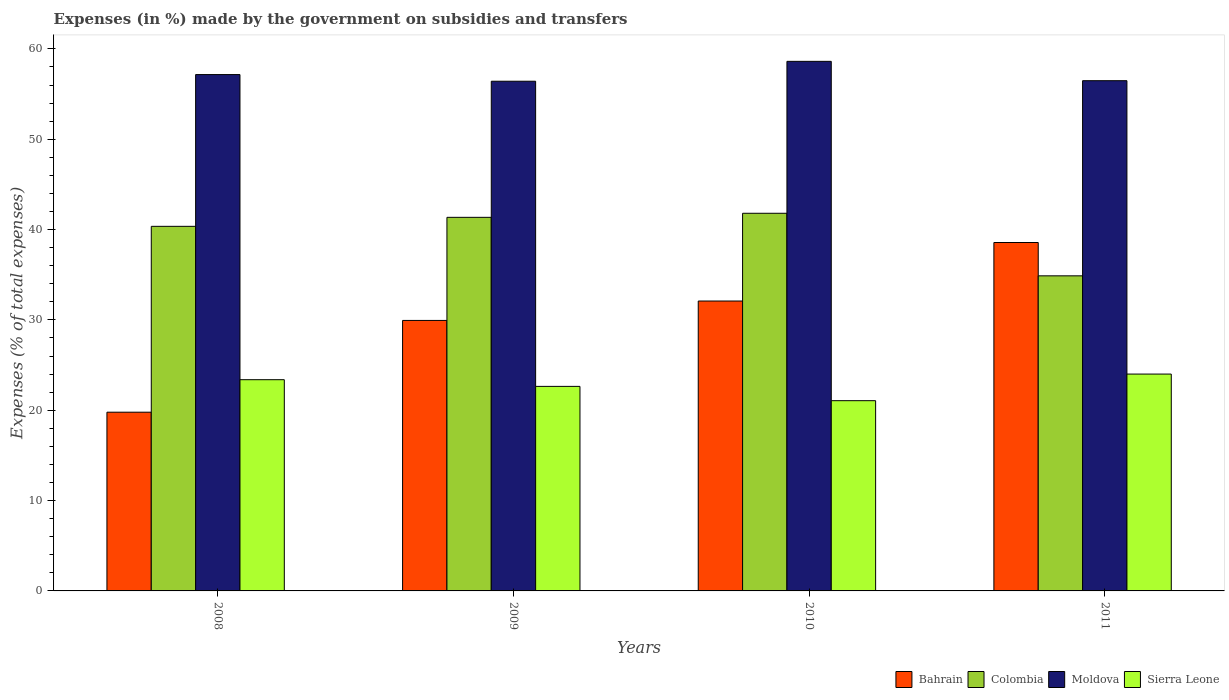How many different coloured bars are there?
Offer a very short reply. 4. How many groups of bars are there?
Your answer should be very brief. 4. Are the number of bars on each tick of the X-axis equal?
Your response must be concise. Yes. What is the label of the 4th group of bars from the left?
Provide a succinct answer. 2011. What is the percentage of expenses made by the government on subsidies and transfers in Moldova in 2010?
Offer a very short reply. 58.62. Across all years, what is the maximum percentage of expenses made by the government on subsidies and transfers in Colombia?
Provide a short and direct response. 41.81. Across all years, what is the minimum percentage of expenses made by the government on subsidies and transfers in Bahrain?
Your answer should be compact. 19.78. In which year was the percentage of expenses made by the government on subsidies and transfers in Colombia minimum?
Ensure brevity in your answer.  2011. What is the total percentage of expenses made by the government on subsidies and transfers in Moldova in the graph?
Offer a terse response. 228.69. What is the difference between the percentage of expenses made by the government on subsidies and transfers in Moldova in 2008 and that in 2010?
Your answer should be very brief. -1.46. What is the difference between the percentage of expenses made by the government on subsidies and transfers in Bahrain in 2011 and the percentage of expenses made by the government on subsidies and transfers in Moldova in 2010?
Your response must be concise. -20.05. What is the average percentage of expenses made by the government on subsidies and transfers in Sierra Leone per year?
Keep it short and to the point. 22.77. In the year 2009, what is the difference between the percentage of expenses made by the government on subsidies and transfers in Colombia and percentage of expenses made by the government on subsidies and transfers in Sierra Leone?
Make the answer very short. 18.71. In how many years, is the percentage of expenses made by the government on subsidies and transfers in Sierra Leone greater than 48 %?
Your answer should be very brief. 0. What is the ratio of the percentage of expenses made by the government on subsidies and transfers in Sierra Leone in 2008 to that in 2009?
Offer a terse response. 1.03. Is the percentage of expenses made by the government on subsidies and transfers in Moldova in 2010 less than that in 2011?
Offer a terse response. No. What is the difference between the highest and the second highest percentage of expenses made by the government on subsidies and transfers in Bahrain?
Provide a succinct answer. 6.48. What is the difference between the highest and the lowest percentage of expenses made by the government on subsidies and transfers in Colombia?
Offer a very short reply. 6.93. In how many years, is the percentage of expenses made by the government on subsidies and transfers in Colombia greater than the average percentage of expenses made by the government on subsidies and transfers in Colombia taken over all years?
Offer a terse response. 3. Is it the case that in every year, the sum of the percentage of expenses made by the government on subsidies and transfers in Bahrain and percentage of expenses made by the government on subsidies and transfers in Sierra Leone is greater than the sum of percentage of expenses made by the government on subsidies and transfers in Moldova and percentage of expenses made by the government on subsidies and transfers in Colombia?
Your answer should be compact. No. What does the 2nd bar from the right in 2010 represents?
Your answer should be very brief. Moldova. Is it the case that in every year, the sum of the percentage of expenses made by the government on subsidies and transfers in Colombia and percentage of expenses made by the government on subsidies and transfers in Moldova is greater than the percentage of expenses made by the government on subsidies and transfers in Bahrain?
Offer a very short reply. Yes. Are the values on the major ticks of Y-axis written in scientific E-notation?
Your answer should be very brief. No. Where does the legend appear in the graph?
Offer a terse response. Bottom right. What is the title of the graph?
Offer a very short reply. Expenses (in %) made by the government on subsidies and transfers. What is the label or title of the Y-axis?
Keep it short and to the point. Expenses (% of total expenses). What is the Expenses (% of total expenses) of Bahrain in 2008?
Provide a succinct answer. 19.78. What is the Expenses (% of total expenses) in Colombia in 2008?
Your response must be concise. 40.36. What is the Expenses (% of total expenses) of Moldova in 2008?
Keep it short and to the point. 57.16. What is the Expenses (% of total expenses) in Sierra Leone in 2008?
Your answer should be very brief. 23.38. What is the Expenses (% of total expenses) in Bahrain in 2009?
Ensure brevity in your answer.  29.94. What is the Expenses (% of total expenses) in Colombia in 2009?
Your answer should be very brief. 41.36. What is the Expenses (% of total expenses) in Moldova in 2009?
Make the answer very short. 56.42. What is the Expenses (% of total expenses) of Sierra Leone in 2009?
Give a very brief answer. 22.64. What is the Expenses (% of total expenses) in Bahrain in 2010?
Give a very brief answer. 32.09. What is the Expenses (% of total expenses) in Colombia in 2010?
Make the answer very short. 41.81. What is the Expenses (% of total expenses) of Moldova in 2010?
Ensure brevity in your answer.  58.62. What is the Expenses (% of total expenses) of Sierra Leone in 2010?
Give a very brief answer. 21.06. What is the Expenses (% of total expenses) of Bahrain in 2011?
Make the answer very short. 38.57. What is the Expenses (% of total expenses) of Colombia in 2011?
Keep it short and to the point. 34.88. What is the Expenses (% of total expenses) in Moldova in 2011?
Provide a short and direct response. 56.48. What is the Expenses (% of total expenses) of Sierra Leone in 2011?
Your answer should be compact. 24.01. Across all years, what is the maximum Expenses (% of total expenses) in Bahrain?
Provide a succinct answer. 38.57. Across all years, what is the maximum Expenses (% of total expenses) in Colombia?
Offer a very short reply. 41.81. Across all years, what is the maximum Expenses (% of total expenses) of Moldova?
Ensure brevity in your answer.  58.62. Across all years, what is the maximum Expenses (% of total expenses) of Sierra Leone?
Keep it short and to the point. 24.01. Across all years, what is the minimum Expenses (% of total expenses) of Bahrain?
Your response must be concise. 19.78. Across all years, what is the minimum Expenses (% of total expenses) of Colombia?
Offer a terse response. 34.88. Across all years, what is the minimum Expenses (% of total expenses) in Moldova?
Give a very brief answer. 56.42. Across all years, what is the minimum Expenses (% of total expenses) of Sierra Leone?
Make the answer very short. 21.06. What is the total Expenses (% of total expenses) of Bahrain in the graph?
Offer a very short reply. 120.39. What is the total Expenses (% of total expenses) in Colombia in the graph?
Keep it short and to the point. 158.4. What is the total Expenses (% of total expenses) of Moldova in the graph?
Your response must be concise. 228.69. What is the total Expenses (% of total expenses) of Sierra Leone in the graph?
Keep it short and to the point. 91.09. What is the difference between the Expenses (% of total expenses) in Bahrain in 2008 and that in 2009?
Your answer should be very brief. -10.16. What is the difference between the Expenses (% of total expenses) in Colombia in 2008 and that in 2009?
Keep it short and to the point. -1. What is the difference between the Expenses (% of total expenses) in Moldova in 2008 and that in 2009?
Your answer should be very brief. 0.74. What is the difference between the Expenses (% of total expenses) of Sierra Leone in 2008 and that in 2009?
Keep it short and to the point. 0.74. What is the difference between the Expenses (% of total expenses) in Bahrain in 2008 and that in 2010?
Offer a terse response. -12.31. What is the difference between the Expenses (% of total expenses) in Colombia in 2008 and that in 2010?
Provide a short and direct response. -1.45. What is the difference between the Expenses (% of total expenses) of Moldova in 2008 and that in 2010?
Your answer should be very brief. -1.46. What is the difference between the Expenses (% of total expenses) in Sierra Leone in 2008 and that in 2010?
Your answer should be very brief. 2.32. What is the difference between the Expenses (% of total expenses) of Bahrain in 2008 and that in 2011?
Offer a terse response. -18.78. What is the difference between the Expenses (% of total expenses) in Colombia in 2008 and that in 2011?
Your response must be concise. 5.48. What is the difference between the Expenses (% of total expenses) in Moldova in 2008 and that in 2011?
Offer a very short reply. 0.68. What is the difference between the Expenses (% of total expenses) in Sierra Leone in 2008 and that in 2011?
Give a very brief answer. -0.62. What is the difference between the Expenses (% of total expenses) in Bahrain in 2009 and that in 2010?
Your answer should be compact. -2.15. What is the difference between the Expenses (% of total expenses) in Colombia in 2009 and that in 2010?
Keep it short and to the point. -0.45. What is the difference between the Expenses (% of total expenses) in Moldova in 2009 and that in 2010?
Ensure brevity in your answer.  -2.2. What is the difference between the Expenses (% of total expenses) of Sierra Leone in 2009 and that in 2010?
Offer a very short reply. 1.58. What is the difference between the Expenses (% of total expenses) in Bahrain in 2009 and that in 2011?
Keep it short and to the point. -8.62. What is the difference between the Expenses (% of total expenses) of Colombia in 2009 and that in 2011?
Offer a very short reply. 6.47. What is the difference between the Expenses (% of total expenses) of Moldova in 2009 and that in 2011?
Your answer should be very brief. -0.06. What is the difference between the Expenses (% of total expenses) in Sierra Leone in 2009 and that in 2011?
Keep it short and to the point. -1.36. What is the difference between the Expenses (% of total expenses) in Bahrain in 2010 and that in 2011?
Ensure brevity in your answer.  -6.48. What is the difference between the Expenses (% of total expenses) in Colombia in 2010 and that in 2011?
Your response must be concise. 6.93. What is the difference between the Expenses (% of total expenses) in Moldova in 2010 and that in 2011?
Give a very brief answer. 2.14. What is the difference between the Expenses (% of total expenses) in Sierra Leone in 2010 and that in 2011?
Keep it short and to the point. -2.95. What is the difference between the Expenses (% of total expenses) of Bahrain in 2008 and the Expenses (% of total expenses) of Colombia in 2009?
Your response must be concise. -21.57. What is the difference between the Expenses (% of total expenses) of Bahrain in 2008 and the Expenses (% of total expenses) of Moldova in 2009?
Your answer should be compact. -36.64. What is the difference between the Expenses (% of total expenses) in Bahrain in 2008 and the Expenses (% of total expenses) in Sierra Leone in 2009?
Provide a succinct answer. -2.86. What is the difference between the Expenses (% of total expenses) of Colombia in 2008 and the Expenses (% of total expenses) of Moldova in 2009?
Make the answer very short. -16.06. What is the difference between the Expenses (% of total expenses) in Colombia in 2008 and the Expenses (% of total expenses) in Sierra Leone in 2009?
Offer a terse response. 17.72. What is the difference between the Expenses (% of total expenses) of Moldova in 2008 and the Expenses (% of total expenses) of Sierra Leone in 2009?
Offer a very short reply. 34.52. What is the difference between the Expenses (% of total expenses) in Bahrain in 2008 and the Expenses (% of total expenses) in Colombia in 2010?
Provide a succinct answer. -22.02. What is the difference between the Expenses (% of total expenses) in Bahrain in 2008 and the Expenses (% of total expenses) in Moldova in 2010?
Give a very brief answer. -38.84. What is the difference between the Expenses (% of total expenses) in Bahrain in 2008 and the Expenses (% of total expenses) in Sierra Leone in 2010?
Offer a very short reply. -1.27. What is the difference between the Expenses (% of total expenses) in Colombia in 2008 and the Expenses (% of total expenses) in Moldova in 2010?
Your answer should be very brief. -18.26. What is the difference between the Expenses (% of total expenses) in Colombia in 2008 and the Expenses (% of total expenses) in Sierra Leone in 2010?
Give a very brief answer. 19.3. What is the difference between the Expenses (% of total expenses) in Moldova in 2008 and the Expenses (% of total expenses) in Sierra Leone in 2010?
Provide a short and direct response. 36.1. What is the difference between the Expenses (% of total expenses) of Bahrain in 2008 and the Expenses (% of total expenses) of Colombia in 2011?
Your answer should be compact. -15.1. What is the difference between the Expenses (% of total expenses) in Bahrain in 2008 and the Expenses (% of total expenses) in Moldova in 2011?
Keep it short and to the point. -36.7. What is the difference between the Expenses (% of total expenses) in Bahrain in 2008 and the Expenses (% of total expenses) in Sierra Leone in 2011?
Offer a very short reply. -4.22. What is the difference between the Expenses (% of total expenses) in Colombia in 2008 and the Expenses (% of total expenses) in Moldova in 2011?
Provide a succinct answer. -16.12. What is the difference between the Expenses (% of total expenses) in Colombia in 2008 and the Expenses (% of total expenses) in Sierra Leone in 2011?
Make the answer very short. 16.35. What is the difference between the Expenses (% of total expenses) of Moldova in 2008 and the Expenses (% of total expenses) of Sierra Leone in 2011?
Offer a very short reply. 33.15. What is the difference between the Expenses (% of total expenses) in Bahrain in 2009 and the Expenses (% of total expenses) in Colombia in 2010?
Make the answer very short. -11.86. What is the difference between the Expenses (% of total expenses) in Bahrain in 2009 and the Expenses (% of total expenses) in Moldova in 2010?
Your answer should be compact. -28.68. What is the difference between the Expenses (% of total expenses) of Bahrain in 2009 and the Expenses (% of total expenses) of Sierra Leone in 2010?
Ensure brevity in your answer.  8.88. What is the difference between the Expenses (% of total expenses) in Colombia in 2009 and the Expenses (% of total expenses) in Moldova in 2010?
Your answer should be compact. -17.27. What is the difference between the Expenses (% of total expenses) of Colombia in 2009 and the Expenses (% of total expenses) of Sierra Leone in 2010?
Your answer should be compact. 20.3. What is the difference between the Expenses (% of total expenses) in Moldova in 2009 and the Expenses (% of total expenses) in Sierra Leone in 2010?
Ensure brevity in your answer.  35.36. What is the difference between the Expenses (% of total expenses) of Bahrain in 2009 and the Expenses (% of total expenses) of Colombia in 2011?
Ensure brevity in your answer.  -4.94. What is the difference between the Expenses (% of total expenses) in Bahrain in 2009 and the Expenses (% of total expenses) in Moldova in 2011?
Offer a terse response. -26.54. What is the difference between the Expenses (% of total expenses) of Bahrain in 2009 and the Expenses (% of total expenses) of Sierra Leone in 2011?
Your response must be concise. 5.94. What is the difference between the Expenses (% of total expenses) in Colombia in 2009 and the Expenses (% of total expenses) in Moldova in 2011?
Offer a terse response. -15.13. What is the difference between the Expenses (% of total expenses) in Colombia in 2009 and the Expenses (% of total expenses) in Sierra Leone in 2011?
Provide a succinct answer. 17.35. What is the difference between the Expenses (% of total expenses) of Moldova in 2009 and the Expenses (% of total expenses) of Sierra Leone in 2011?
Your answer should be compact. 32.42. What is the difference between the Expenses (% of total expenses) in Bahrain in 2010 and the Expenses (% of total expenses) in Colombia in 2011?
Keep it short and to the point. -2.79. What is the difference between the Expenses (% of total expenses) of Bahrain in 2010 and the Expenses (% of total expenses) of Moldova in 2011?
Offer a terse response. -24.39. What is the difference between the Expenses (% of total expenses) of Bahrain in 2010 and the Expenses (% of total expenses) of Sierra Leone in 2011?
Provide a short and direct response. 8.09. What is the difference between the Expenses (% of total expenses) of Colombia in 2010 and the Expenses (% of total expenses) of Moldova in 2011?
Give a very brief answer. -14.68. What is the difference between the Expenses (% of total expenses) in Colombia in 2010 and the Expenses (% of total expenses) in Sierra Leone in 2011?
Offer a terse response. 17.8. What is the difference between the Expenses (% of total expenses) in Moldova in 2010 and the Expenses (% of total expenses) in Sierra Leone in 2011?
Provide a short and direct response. 34.62. What is the average Expenses (% of total expenses) of Bahrain per year?
Offer a very short reply. 30.1. What is the average Expenses (% of total expenses) of Colombia per year?
Provide a short and direct response. 39.6. What is the average Expenses (% of total expenses) of Moldova per year?
Your answer should be very brief. 57.17. What is the average Expenses (% of total expenses) of Sierra Leone per year?
Ensure brevity in your answer.  22.77. In the year 2008, what is the difference between the Expenses (% of total expenses) of Bahrain and Expenses (% of total expenses) of Colombia?
Offer a terse response. -20.57. In the year 2008, what is the difference between the Expenses (% of total expenses) of Bahrain and Expenses (% of total expenses) of Moldova?
Offer a terse response. -37.38. In the year 2008, what is the difference between the Expenses (% of total expenses) in Bahrain and Expenses (% of total expenses) in Sierra Leone?
Make the answer very short. -3.6. In the year 2008, what is the difference between the Expenses (% of total expenses) of Colombia and Expenses (% of total expenses) of Moldova?
Ensure brevity in your answer.  -16.8. In the year 2008, what is the difference between the Expenses (% of total expenses) of Colombia and Expenses (% of total expenses) of Sierra Leone?
Keep it short and to the point. 16.98. In the year 2008, what is the difference between the Expenses (% of total expenses) of Moldova and Expenses (% of total expenses) of Sierra Leone?
Keep it short and to the point. 33.78. In the year 2009, what is the difference between the Expenses (% of total expenses) of Bahrain and Expenses (% of total expenses) of Colombia?
Your answer should be compact. -11.41. In the year 2009, what is the difference between the Expenses (% of total expenses) of Bahrain and Expenses (% of total expenses) of Moldova?
Offer a terse response. -26.48. In the year 2009, what is the difference between the Expenses (% of total expenses) of Bahrain and Expenses (% of total expenses) of Sierra Leone?
Keep it short and to the point. 7.3. In the year 2009, what is the difference between the Expenses (% of total expenses) of Colombia and Expenses (% of total expenses) of Moldova?
Keep it short and to the point. -15.07. In the year 2009, what is the difference between the Expenses (% of total expenses) in Colombia and Expenses (% of total expenses) in Sierra Leone?
Your answer should be very brief. 18.71. In the year 2009, what is the difference between the Expenses (% of total expenses) in Moldova and Expenses (% of total expenses) in Sierra Leone?
Provide a succinct answer. 33.78. In the year 2010, what is the difference between the Expenses (% of total expenses) in Bahrain and Expenses (% of total expenses) in Colombia?
Make the answer very short. -9.71. In the year 2010, what is the difference between the Expenses (% of total expenses) of Bahrain and Expenses (% of total expenses) of Moldova?
Keep it short and to the point. -26.53. In the year 2010, what is the difference between the Expenses (% of total expenses) in Bahrain and Expenses (% of total expenses) in Sierra Leone?
Your answer should be compact. 11.03. In the year 2010, what is the difference between the Expenses (% of total expenses) in Colombia and Expenses (% of total expenses) in Moldova?
Ensure brevity in your answer.  -16.82. In the year 2010, what is the difference between the Expenses (% of total expenses) of Colombia and Expenses (% of total expenses) of Sierra Leone?
Provide a short and direct response. 20.75. In the year 2010, what is the difference between the Expenses (% of total expenses) of Moldova and Expenses (% of total expenses) of Sierra Leone?
Your answer should be very brief. 37.56. In the year 2011, what is the difference between the Expenses (% of total expenses) of Bahrain and Expenses (% of total expenses) of Colombia?
Give a very brief answer. 3.69. In the year 2011, what is the difference between the Expenses (% of total expenses) of Bahrain and Expenses (% of total expenses) of Moldova?
Make the answer very short. -17.91. In the year 2011, what is the difference between the Expenses (% of total expenses) of Bahrain and Expenses (% of total expenses) of Sierra Leone?
Offer a terse response. 14.56. In the year 2011, what is the difference between the Expenses (% of total expenses) of Colombia and Expenses (% of total expenses) of Moldova?
Provide a succinct answer. -21.6. In the year 2011, what is the difference between the Expenses (% of total expenses) of Colombia and Expenses (% of total expenses) of Sierra Leone?
Make the answer very short. 10.87. In the year 2011, what is the difference between the Expenses (% of total expenses) of Moldova and Expenses (% of total expenses) of Sierra Leone?
Provide a short and direct response. 32.48. What is the ratio of the Expenses (% of total expenses) of Bahrain in 2008 to that in 2009?
Offer a very short reply. 0.66. What is the ratio of the Expenses (% of total expenses) in Colombia in 2008 to that in 2009?
Provide a succinct answer. 0.98. What is the ratio of the Expenses (% of total expenses) of Moldova in 2008 to that in 2009?
Provide a succinct answer. 1.01. What is the ratio of the Expenses (% of total expenses) in Sierra Leone in 2008 to that in 2009?
Your answer should be very brief. 1.03. What is the ratio of the Expenses (% of total expenses) in Bahrain in 2008 to that in 2010?
Offer a terse response. 0.62. What is the ratio of the Expenses (% of total expenses) in Colombia in 2008 to that in 2010?
Your answer should be very brief. 0.97. What is the ratio of the Expenses (% of total expenses) in Moldova in 2008 to that in 2010?
Offer a very short reply. 0.97. What is the ratio of the Expenses (% of total expenses) of Sierra Leone in 2008 to that in 2010?
Provide a short and direct response. 1.11. What is the ratio of the Expenses (% of total expenses) in Bahrain in 2008 to that in 2011?
Provide a short and direct response. 0.51. What is the ratio of the Expenses (% of total expenses) in Colombia in 2008 to that in 2011?
Your answer should be very brief. 1.16. What is the ratio of the Expenses (% of total expenses) of Bahrain in 2009 to that in 2010?
Keep it short and to the point. 0.93. What is the ratio of the Expenses (% of total expenses) in Moldova in 2009 to that in 2010?
Ensure brevity in your answer.  0.96. What is the ratio of the Expenses (% of total expenses) in Sierra Leone in 2009 to that in 2010?
Your answer should be compact. 1.08. What is the ratio of the Expenses (% of total expenses) in Bahrain in 2009 to that in 2011?
Provide a short and direct response. 0.78. What is the ratio of the Expenses (% of total expenses) in Colombia in 2009 to that in 2011?
Provide a short and direct response. 1.19. What is the ratio of the Expenses (% of total expenses) in Moldova in 2009 to that in 2011?
Give a very brief answer. 1. What is the ratio of the Expenses (% of total expenses) of Sierra Leone in 2009 to that in 2011?
Ensure brevity in your answer.  0.94. What is the ratio of the Expenses (% of total expenses) of Bahrain in 2010 to that in 2011?
Provide a short and direct response. 0.83. What is the ratio of the Expenses (% of total expenses) in Colombia in 2010 to that in 2011?
Your answer should be compact. 1.2. What is the ratio of the Expenses (% of total expenses) in Moldova in 2010 to that in 2011?
Your answer should be very brief. 1.04. What is the ratio of the Expenses (% of total expenses) in Sierra Leone in 2010 to that in 2011?
Your response must be concise. 0.88. What is the difference between the highest and the second highest Expenses (% of total expenses) of Bahrain?
Your response must be concise. 6.48. What is the difference between the highest and the second highest Expenses (% of total expenses) in Colombia?
Your response must be concise. 0.45. What is the difference between the highest and the second highest Expenses (% of total expenses) in Moldova?
Your answer should be compact. 1.46. What is the difference between the highest and the second highest Expenses (% of total expenses) of Sierra Leone?
Make the answer very short. 0.62. What is the difference between the highest and the lowest Expenses (% of total expenses) of Bahrain?
Ensure brevity in your answer.  18.78. What is the difference between the highest and the lowest Expenses (% of total expenses) in Colombia?
Provide a short and direct response. 6.93. What is the difference between the highest and the lowest Expenses (% of total expenses) of Moldova?
Your answer should be compact. 2.2. What is the difference between the highest and the lowest Expenses (% of total expenses) of Sierra Leone?
Give a very brief answer. 2.95. 